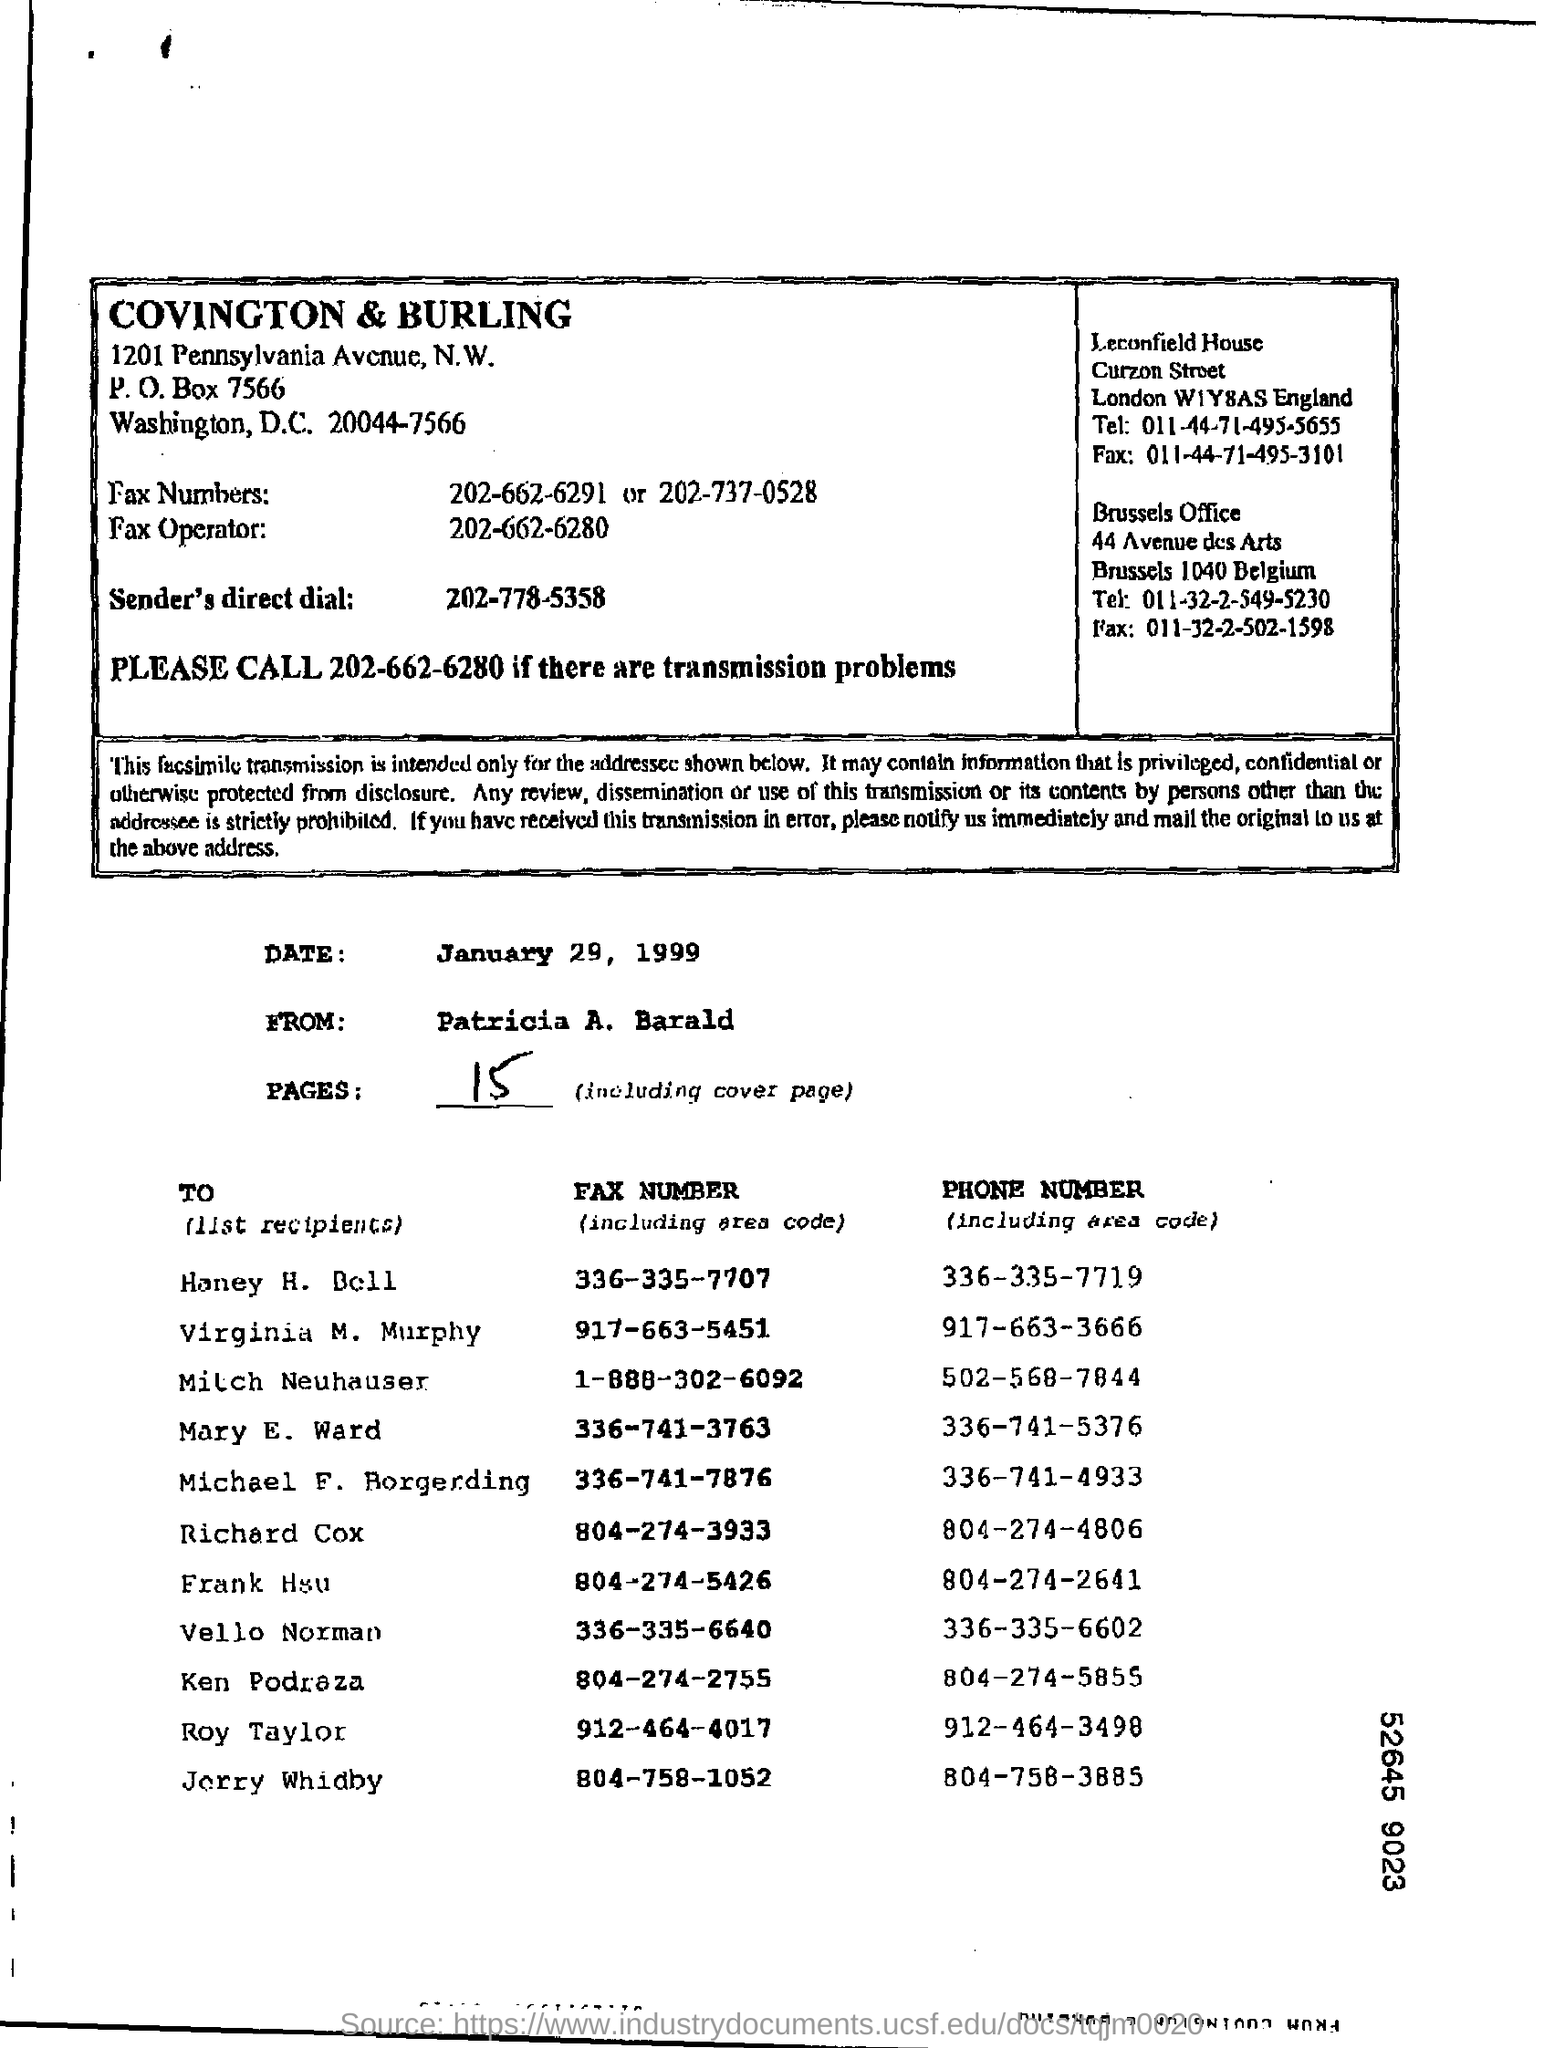What is the P.O Box Number ?
Give a very brief answer. 7566. What is the date mentioned in the document ?
Your response must be concise. January 29, 1999. Who is the sender of this fax?
Keep it short and to the point. Patricia A. Barald. What is the total no of pages in the fax including cover page?
Your answer should be very brief. 15. What is the Phone Number of Mary E. Ward?
Provide a short and direct response. 336-741-5376. What is the Fax Number of Roy Taylor ?
Give a very brief answer. 912-464-4017. What is the Fax Number of Richard Cox ?
Make the answer very short. 804-274-3933. What is the Phone number of Vello Norman ?
Make the answer very short. 336-335-6602. 